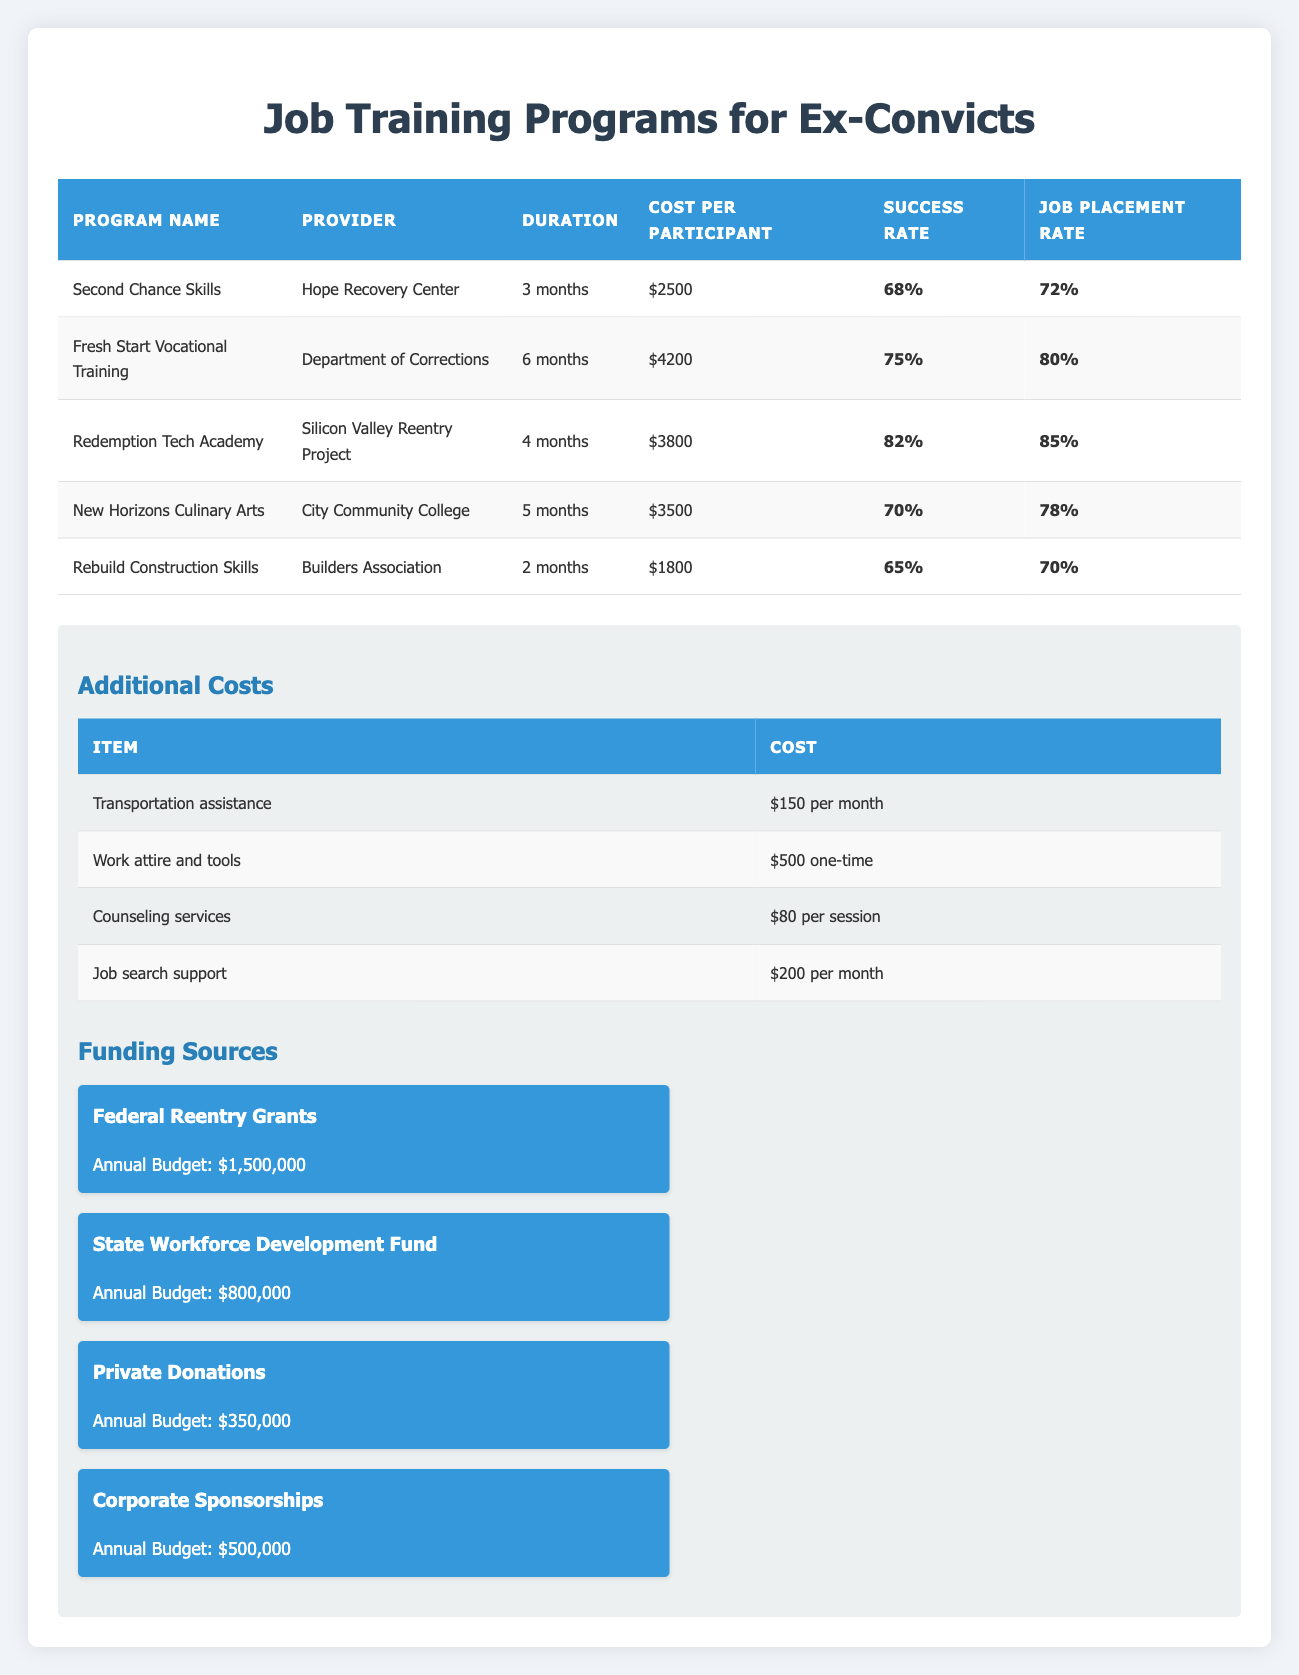What is the cost per participant for the "Redemption Tech Academy"? The "Redemption Tech Academy" costs $3,800 per participant as indicated in the table.
Answer: 3800 Which job training program has the highest job placement rate? The "Redemption Tech Academy" has the highest job placement rate of 85%.
Answer: 85 What is the total cost per participant for the "Fresh Start Vocational Training," including additional costs? The base cost is $4,200. Adding the transportation assistance ($150 per month * 6 months = $900), the total cost is $4,200 + $900 = $5,100.
Answer: 5100 Is the success rate for "Rebuild Construction Skills" higher than 70%? The success rate for "Rebuild Construction Skills" is 65%, which is not higher than 70%.
Answer: No What is the average success rate of all job training programs listed? To calculate the average success rate: (68 + 75 + 82 + 70 + 65) / 5 = 72. Therefore, the average success rate is 72%.
Answer: 72 Does the "Hope Recovery Center" have a program with a cost higher than $3,000? "Second Chance Skills," offered by the Hope Recovery Center, costs $2,500 which is not higher than $3,000.
Answer: No How much funding does the "State Workforce Development Fund" have compared to "Private Donations"? The "State Workforce Development Fund" has $800,000, while "Private Donations" have $350,000. The difference is $800,000 - $350,000 = $450,000.
Answer: 450000 What is the total duration in months for all training programs combined? The total duration is 3 + 6 + 4 + 5 + 2 = 20 months.
Answer: 20 Which job training program is the least expensive? The "Rebuild Construction Skills" program is the least expensive at $1,800 per participant.
Answer: 1800 